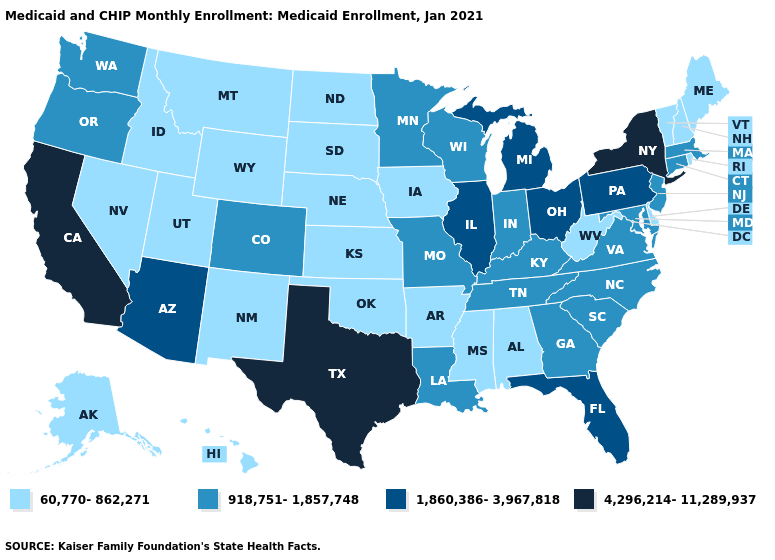Name the states that have a value in the range 60,770-862,271?
Quick response, please. Alabama, Alaska, Arkansas, Delaware, Hawaii, Idaho, Iowa, Kansas, Maine, Mississippi, Montana, Nebraska, Nevada, New Hampshire, New Mexico, North Dakota, Oklahoma, Rhode Island, South Dakota, Utah, Vermont, West Virginia, Wyoming. What is the value of Michigan?
Answer briefly. 1,860,386-3,967,818. Does Arkansas have the lowest value in the USA?
Keep it brief. Yes. What is the highest value in states that border North Carolina?
Write a very short answer. 918,751-1,857,748. Name the states that have a value in the range 918,751-1,857,748?
Short answer required. Colorado, Connecticut, Georgia, Indiana, Kentucky, Louisiana, Maryland, Massachusetts, Minnesota, Missouri, New Jersey, North Carolina, Oregon, South Carolina, Tennessee, Virginia, Washington, Wisconsin. Name the states that have a value in the range 918,751-1,857,748?
Give a very brief answer. Colorado, Connecticut, Georgia, Indiana, Kentucky, Louisiana, Maryland, Massachusetts, Minnesota, Missouri, New Jersey, North Carolina, Oregon, South Carolina, Tennessee, Virginia, Washington, Wisconsin. What is the highest value in the South ?
Give a very brief answer. 4,296,214-11,289,937. Name the states that have a value in the range 4,296,214-11,289,937?
Be succinct. California, New York, Texas. Does the map have missing data?
Short answer required. No. How many symbols are there in the legend?
Give a very brief answer. 4. Name the states that have a value in the range 60,770-862,271?
Write a very short answer. Alabama, Alaska, Arkansas, Delaware, Hawaii, Idaho, Iowa, Kansas, Maine, Mississippi, Montana, Nebraska, Nevada, New Hampshire, New Mexico, North Dakota, Oklahoma, Rhode Island, South Dakota, Utah, Vermont, West Virginia, Wyoming. Name the states that have a value in the range 1,860,386-3,967,818?
Quick response, please. Arizona, Florida, Illinois, Michigan, Ohio, Pennsylvania. Name the states that have a value in the range 918,751-1,857,748?
Be succinct. Colorado, Connecticut, Georgia, Indiana, Kentucky, Louisiana, Maryland, Massachusetts, Minnesota, Missouri, New Jersey, North Carolina, Oregon, South Carolina, Tennessee, Virginia, Washington, Wisconsin. What is the value of Nebraska?
Concise answer only. 60,770-862,271. What is the highest value in the Northeast ?
Answer briefly. 4,296,214-11,289,937. 